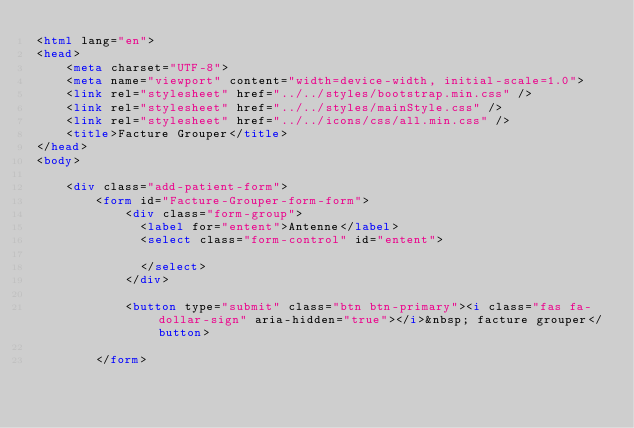<code> <loc_0><loc_0><loc_500><loc_500><_HTML_><html lang="en">
<head>
    <meta charset="UTF-8">
    <meta name="viewport" content="width=device-width, initial-scale=1.0">
    <link rel="stylesheet" href="../../styles/bootstrap.min.css" />
    <link rel="stylesheet" href="../../styles/mainStyle.css" />
    <link rel="stylesheet" href="../../icons/css/all.min.css" />
    <title>Facture Grouper</title>
</head>
<body>

    <div class="add-patient-form">
        <form id="Facture-Grouper-form-form">
            <div class="form-group">
              <label for="entent">Antenne</label>
              <select class="form-control" id="entent">
                
              </select>
            </div> 
    
            <button type="submit" class="btn btn-primary"><i class="fas fa-dollar-sign" aria-hidden="true"></i>&nbsp; facture grouper</button>
    
        </form></code> 